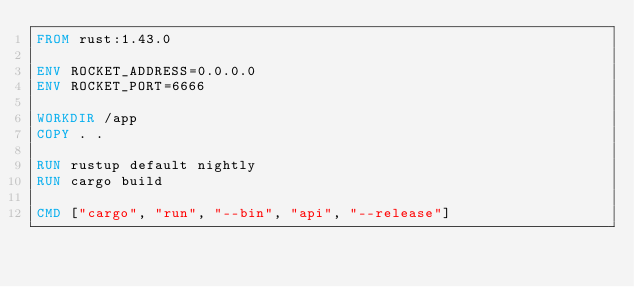<code> <loc_0><loc_0><loc_500><loc_500><_Dockerfile_>FROM rust:1.43.0

ENV ROCKET_ADDRESS=0.0.0.0
ENV ROCKET_PORT=6666

WORKDIR /app
COPY . .

RUN rustup default nightly
RUN cargo build

CMD ["cargo", "run", "--bin", "api", "--release"]
</code> 